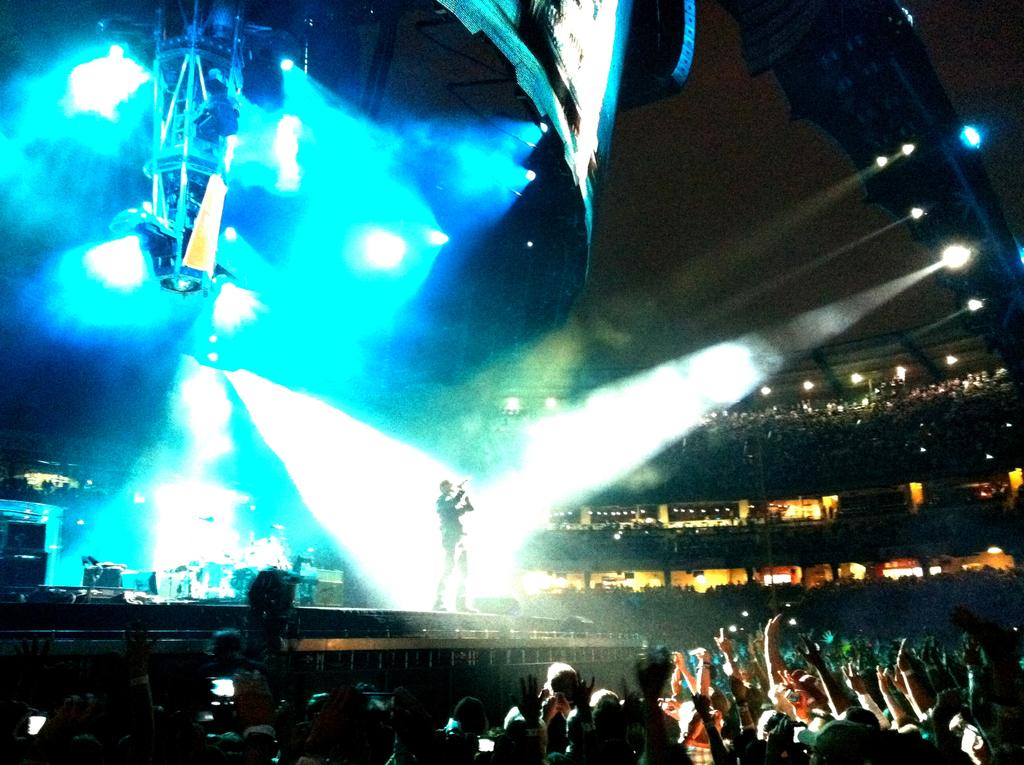What is the main structure in the image? There is a stage in the image. Who or what is on the stage? A person is present on the stage. What atmospheric phenomenon can be seen in the image? There are lightnings visible in the image. What is the composition of the crowd at the bottom of the image? There is a crowd at the bottom of the image. What type of neck accessory is the person on the stage wearing? There is no information about the person's neck accessory in the image. 